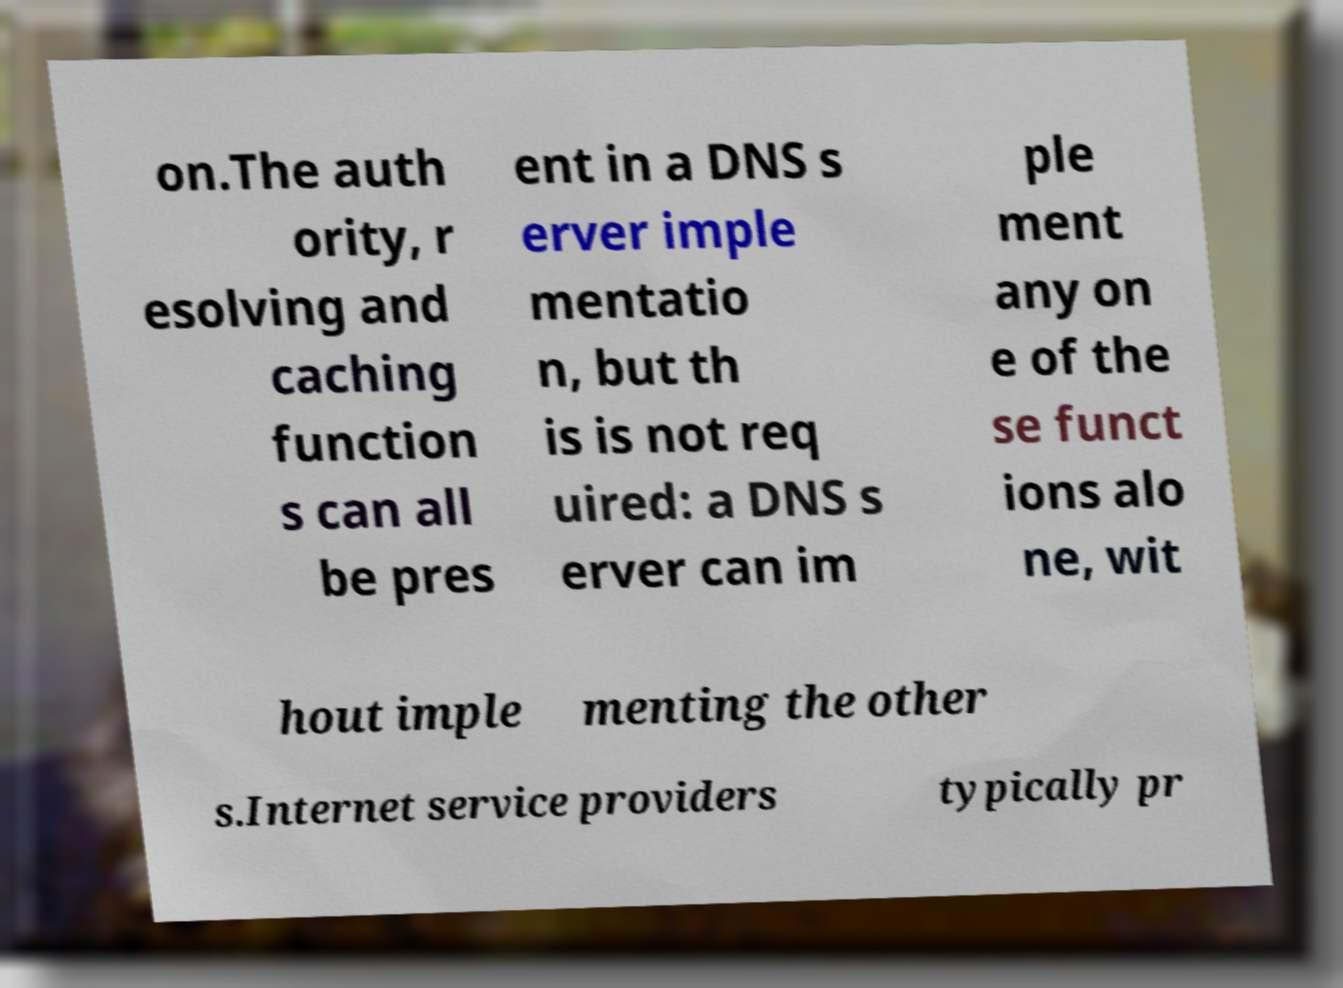I need the written content from this picture converted into text. Can you do that? on.The auth ority, r esolving and caching function s can all be pres ent in a DNS s erver imple mentatio n, but th is is not req uired: a DNS s erver can im ple ment any on e of the se funct ions alo ne, wit hout imple menting the other s.Internet service providers typically pr 